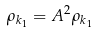Convert formula to latex. <formula><loc_0><loc_0><loc_500><loc_500>\rho _ { k _ { 1 } } = A ^ { 2 } \rho _ { k _ { 1 } }</formula> 